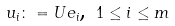<formula> <loc_0><loc_0><loc_500><loc_500>u _ { i } \colon = U e _ { i } \text {, } 1 \leq i \leq m</formula> 